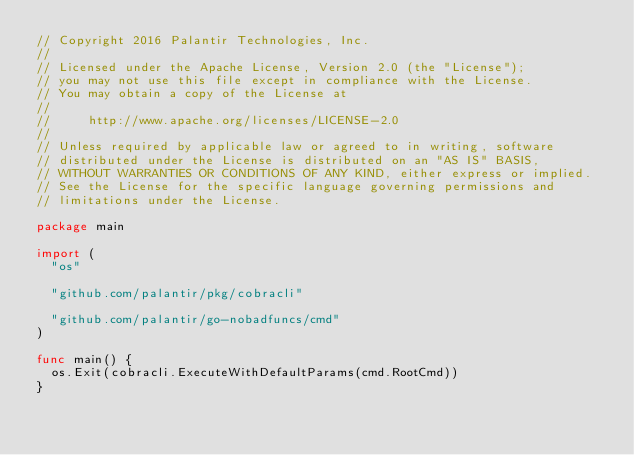<code> <loc_0><loc_0><loc_500><loc_500><_Go_>// Copyright 2016 Palantir Technologies, Inc.
//
// Licensed under the Apache License, Version 2.0 (the "License");
// you may not use this file except in compliance with the License.
// You may obtain a copy of the License at
//
//     http://www.apache.org/licenses/LICENSE-2.0
//
// Unless required by applicable law or agreed to in writing, software
// distributed under the License is distributed on an "AS IS" BASIS,
// WITHOUT WARRANTIES OR CONDITIONS OF ANY KIND, either express or implied.
// See the License for the specific language governing permissions and
// limitations under the License.

package main

import (
	"os"

	"github.com/palantir/pkg/cobracli"

	"github.com/palantir/go-nobadfuncs/cmd"
)

func main() {
	os.Exit(cobracli.ExecuteWithDefaultParams(cmd.RootCmd))
}
</code> 